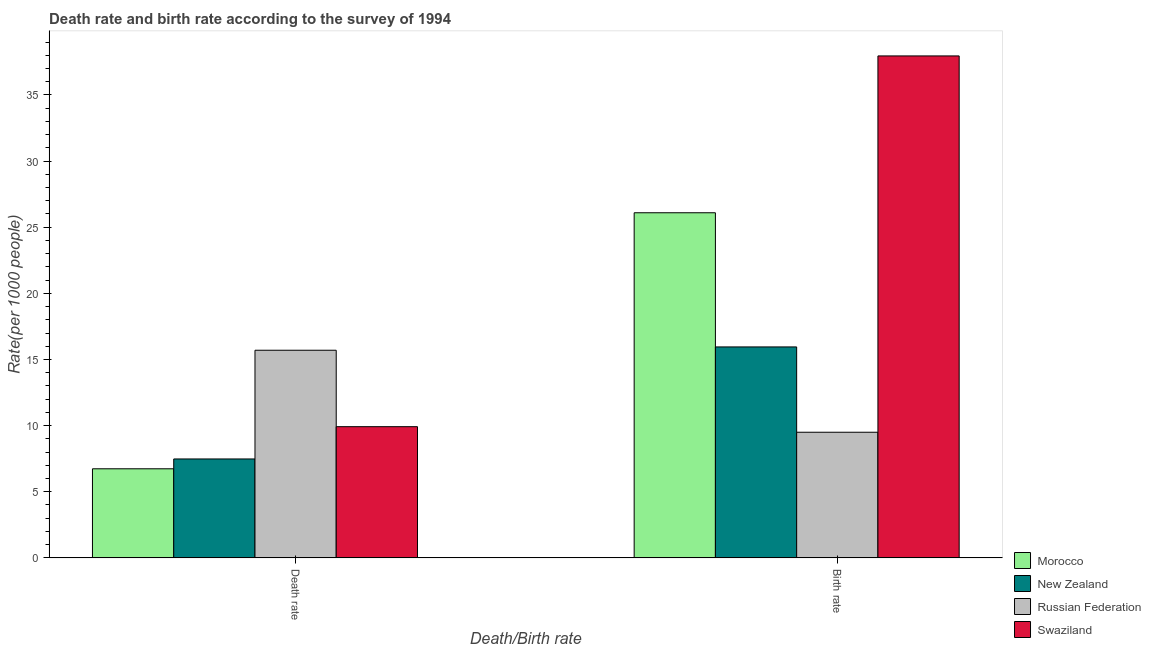How many groups of bars are there?
Your answer should be compact. 2. Are the number of bars per tick equal to the number of legend labels?
Provide a succinct answer. Yes. How many bars are there on the 2nd tick from the left?
Ensure brevity in your answer.  4. What is the label of the 1st group of bars from the left?
Keep it short and to the point. Death rate. What is the birth rate in New Zealand?
Provide a short and direct response. 15.95. Across all countries, what is the maximum death rate?
Provide a succinct answer. 15.7. Across all countries, what is the minimum death rate?
Your answer should be very brief. 6.74. In which country was the birth rate maximum?
Offer a terse response. Swaziland. In which country was the birth rate minimum?
Keep it short and to the point. Russian Federation. What is the total birth rate in the graph?
Offer a terse response. 89.5. What is the difference between the birth rate in New Zealand and that in Swaziland?
Offer a very short reply. -22. What is the average birth rate per country?
Ensure brevity in your answer.  22.37. What is the difference between the death rate and birth rate in New Zealand?
Offer a terse response. -8.47. In how many countries, is the death rate greater than 20 ?
Ensure brevity in your answer.  0. What is the ratio of the birth rate in Morocco to that in Swaziland?
Provide a short and direct response. 0.69. Is the death rate in Russian Federation less than that in Swaziland?
Your response must be concise. No. In how many countries, is the death rate greater than the average death rate taken over all countries?
Your response must be concise. 1. What does the 2nd bar from the left in Death rate represents?
Keep it short and to the point. New Zealand. What does the 4th bar from the right in Death rate represents?
Make the answer very short. Morocco. Are all the bars in the graph horizontal?
Make the answer very short. No. How many countries are there in the graph?
Offer a very short reply. 4. Are the values on the major ticks of Y-axis written in scientific E-notation?
Provide a short and direct response. No. Where does the legend appear in the graph?
Your response must be concise. Bottom right. How many legend labels are there?
Your answer should be very brief. 4. What is the title of the graph?
Your answer should be compact. Death rate and birth rate according to the survey of 1994. What is the label or title of the X-axis?
Give a very brief answer. Death/Birth rate. What is the label or title of the Y-axis?
Offer a very short reply. Rate(per 1000 people). What is the Rate(per 1000 people) of Morocco in Death rate?
Make the answer very short. 6.74. What is the Rate(per 1000 people) in New Zealand in Death rate?
Your answer should be very brief. 7.48. What is the Rate(per 1000 people) of Swaziland in Death rate?
Make the answer very short. 9.92. What is the Rate(per 1000 people) in Morocco in Birth rate?
Keep it short and to the point. 26.09. What is the Rate(per 1000 people) in New Zealand in Birth rate?
Your response must be concise. 15.95. What is the Rate(per 1000 people) of Swaziland in Birth rate?
Offer a very short reply. 37.95. Across all Death/Birth rate, what is the maximum Rate(per 1000 people) in Morocco?
Provide a short and direct response. 26.09. Across all Death/Birth rate, what is the maximum Rate(per 1000 people) of New Zealand?
Your answer should be very brief. 15.95. Across all Death/Birth rate, what is the maximum Rate(per 1000 people) of Russian Federation?
Offer a terse response. 15.7. Across all Death/Birth rate, what is the maximum Rate(per 1000 people) of Swaziland?
Offer a terse response. 37.95. Across all Death/Birth rate, what is the minimum Rate(per 1000 people) in Morocco?
Ensure brevity in your answer.  6.74. Across all Death/Birth rate, what is the minimum Rate(per 1000 people) in New Zealand?
Provide a short and direct response. 7.48. Across all Death/Birth rate, what is the minimum Rate(per 1000 people) in Swaziland?
Provide a succinct answer. 9.92. What is the total Rate(per 1000 people) in Morocco in the graph?
Offer a terse response. 32.83. What is the total Rate(per 1000 people) of New Zealand in the graph?
Ensure brevity in your answer.  23.43. What is the total Rate(per 1000 people) in Russian Federation in the graph?
Keep it short and to the point. 25.2. What is the total Rate(per 1000 people) of Swaziland in the graph?
Your answer should be very brief. 47.87. What is the difference between the Rate(per 1000 people) of Morocco in Death rate and that in Birth rate?
Ensure brevity in your answer.  -19.36. What is the difference between the Rate(per 1000 people) of New Zealand in Death rate and that in Birth rate?
Your answer should be very brief. -8.47. What is the difference between the Rate(per 1000 people) in Russian Federation in Death rate and that in Birth rate?
Make the answer very short. 6.2. What is the difference between the Rate(per 1000 people) in Swaziland in Death rate and that in Birth rate?
Provide a short and direct response. -28.03. What is the difference between the Rate(per 1000 people) of Morocco in Death rate and the Rate(per 1000 people) of New Zealand in Birth rate?
Provide a succinct answer. -9.21. What is the difference between the Rate(per 1000 people) in Morocco in Death rate and the Rate(per 1000 people) in Russian Federation in Birth rate?
Provide a short and direct response. -2.76. What is the difference between the Rate(per 1000 people) in Morocco in Death rate and the Rate(per 1000 people) in Swaziland in Birth rate?
Provide a short and direct response. -31.21. What is the difference between the Rate(per 1000 people) in New Zealand in Death rate and the Rate(per 1000 people) in Russian Federation in Birth rate?
Provide a short and direct response. -2.02. What is the difference between the Rate(per 1000 people) in New Zealand in Death rate and the Rate(per 1000 people) in Swaziland in Birth rate?
Provide a succinct answer. -30.47. What is the difference between the Rate(per 1000 people) in Russian Federation in Death rate and the Rate(per 1000 people) in Swaziland in Birth rate?
Offer a very short reply. -22.25. What is the average Rate(per 1000 people) in Morocco per Death/Birth rate?
Your answer should be very brief. 16.42. What is the average Rate(per 1000 people) of New Zealand per Death/Birth rate?
Ensure brevity in your answer.  11.71. What is the average Rate(per 1000 people) of Swaziland per Death/Birth rate?
Your answer should be very brief. 23.94. What is the difference between the Rate(per 1000 people) in Morocco and Rate(per 1000 people) in New Zealand in Death rate?
Give a very brief answer. -0.74. What is the difference between the Rate(per 1000 people) in Morocco and Rate(per 1000 people) in Russian Federation in Death rate?
Offer a very short reply. -8.96. What is the difference between the Rate(per 1000 people) of Morocco and Rate(per 1000 people) of Swaziland in Death rate?
Your answer should be very brief. -3.18. What is the difference between the Rate(per 1000 people) in New Zealand and Rate(per 1000 people) in Russian Federation in Death rate?
Your answer should be very brief. -8.22. What is the difference between the Rate(per 1000 people) of New Zealand and Rate(per 1000 people) of Swaziland in Death rate?
Your answer should be compact. -2.44. What is the difference between the Rate(per 1000 people) in Russian Federation and Rate(per 1000 people) in Swaziland in Death rate?
Make the answer very short. 5.78. What is the difference between the Rate(per 1000 people) in Morocco and Rate(per 1000 people) in New Zealand in Birth rate?
Your answer should be very brief. 10.14. What is the difference between the Rate(per 1000 people) in Morocco and Rate(per 1000 people) in Russian Federation in Birth rate?
Offer a very short reply. 16.59. What is the difference between the Rate(per 1000 people) in Morocco and Rate(per 1000 people) in Swaziland in Birth rate?
Give a very brief answer. -11.86. What is the difference between the Rate(per 1000 people) of New Zealand and Rate(per 1000 people) of Russian Federation in Birth rate?
Your answer should be very brief. 6.45. What is the difference between the Rate(per 1000 people) of New Zealand and Rate(per 1000 people) of Swaziland in Birth rate?
Keep it short and to the point. -22. What is the difference between the Rate(per 1000 people) in Russian Federation and Rate(per 1000 people) in Swaziland in Birth rate?
Give a very brief answer. -28.45. What is the ratio of the Rate(per 1000 people) of Morocco in Death rate to that in Birth rate?
Offer a terse response. 0.26. What is the ratio of the Rate(per 1000 people) in New Zealand in Death rate to that in Birth rate?
Provide a succinct answer. 0.47. What is the ratio of the Rate(per 1000 people) in Russian Federation in Death rate to that in Birth rate?
Your answer should be compact. 1.65. What is the ratio of the Rate(per 1000 people) of Swaziland in Death rate to that in Birth rate?
Make the answer very short. 0.26. What is the difference between the highest and the second highest Rate(per 1000 people) in Morocco?
Offer a very short reply. 19.36. What is the difference between the highest and the second highest Rate(per 1000 people) of New Zealand?
Offer a terse response. 8.47. What is the difference between the highest and the second highest Rate(per 1000 people) in Russian Federation?
Your answer should be compact. 6.2. What is the difference between the highest and the second highest Rate(per 1000 people) in Swaziland?
Offer a very short reply. 28.03. What is the difference between the highest and the lowest Rate(per 1000 people) in Morocco?
Your answer should be compact. 19.36. What is the difference between the highest and the lowest Rate(per 1000 people) of New Zealand?
Make the answer very short. 8.47. What is the difference between the highest and the lowest Rate(per 1000 people) of Swaziland?
Your response must be concise. 28.03. 